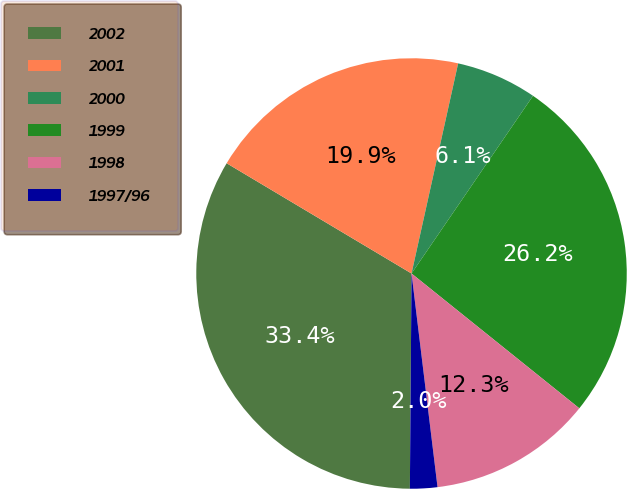Convert chart to OTSL. <chart><loc_0><loc_0><loc_500><loc_500><pie_chart><fcel>2002<fcel>2001<fcel>2000<fcel>1999<fcel>1998<fcel>1997/96<nl><fcel>33.44%<fcel>19.92%<fcel>6.07%<fcel>26.23%<fcel>12.3%<fcel>2.05%<nl></chart> 